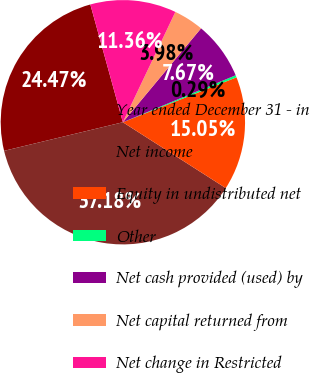Convert chart. <chart><loc_0><loc_0><loc_500><loc_500><pie_chart><fcel>Year ended December 31 - in<fcel>Net income<fcel>Equity in undistributed net<fcel>Other<fcel>Net cash provided (used) by<fcel>Net capital returned from<fcel>Net change in Restricted<nl><fcel>24.47%<fcel>37.18%<fcel>15.05%<fcel>0.29%<fcel>7.67%<fcel>3.98%<fcel>11.36%<nl></chart> 